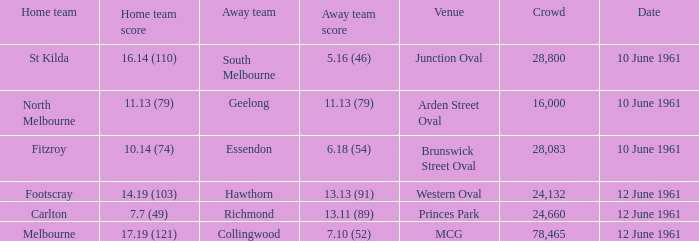Which venue has a crowd over 16,000 and a home team score of 7.7 (49)? Princes Park. 